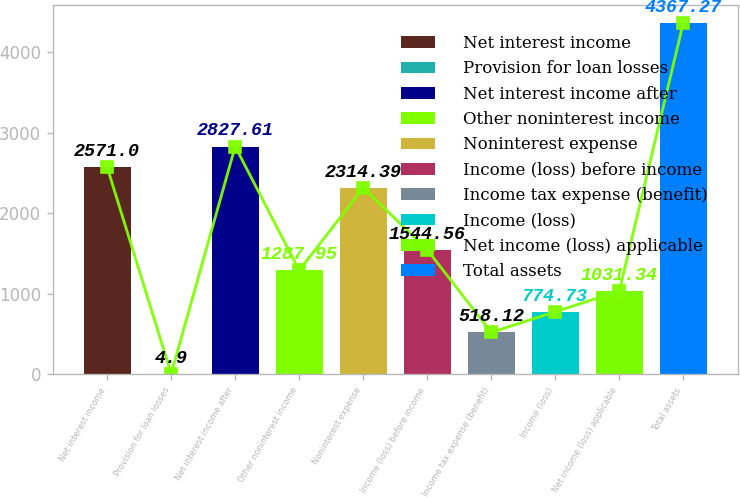<chart> <loc_0><loc_0><loc_500><loc_500><bar_chart><fcel>Net interest income<fcel>Provision for loan losses<fcel>Net interest income after<fcel>Other noninterest income<fcel>Noninterest expense<fcel>Income (loss) before income<fcel>Income tax expense (benefit)<fcel>Income (loss)<fcel>Net income (loss) applicable<fcel>Total assets<nl><fcel>2571<fcel>4.9<fcel>2827.61<fcel>1287.95<fcel>2314.39<fcel>1544.56<fcel>518.12<fcel>774.73<fcel>1031.34<fcel>4367.27<nl></chart> 